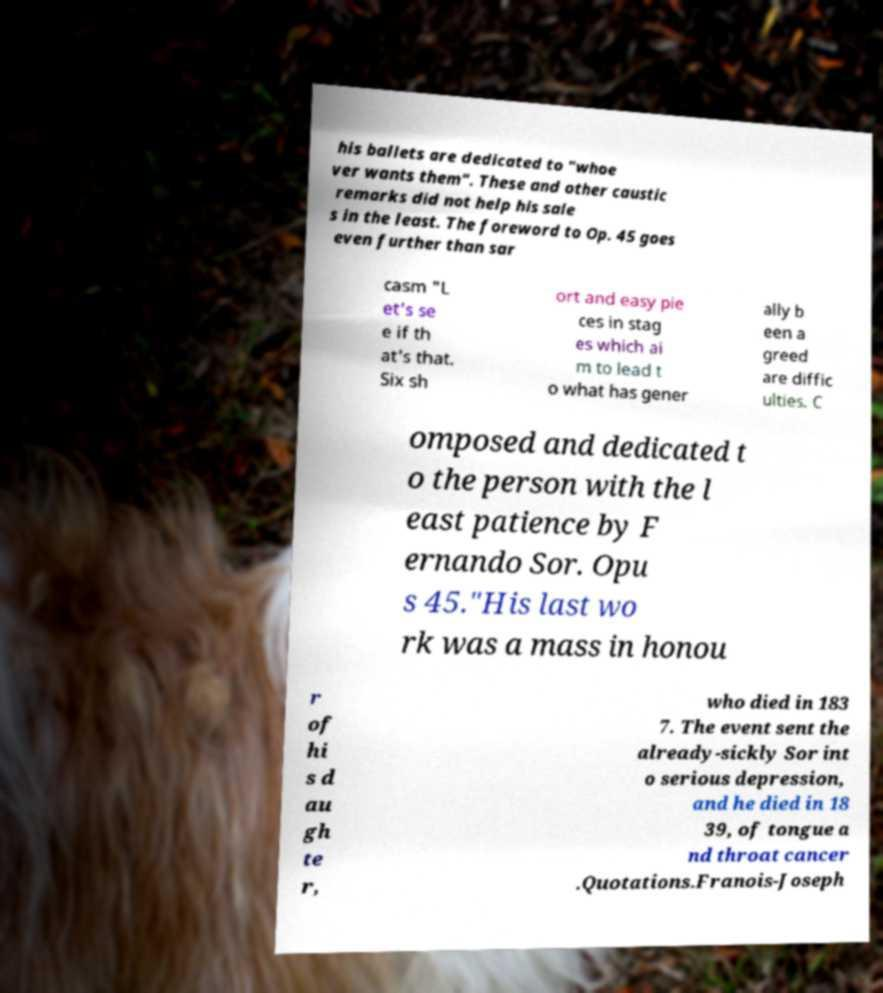Please read and relay the text visible in this image. What does it say? his ballets are dedicated to "whoe ver wants them". These and other caustic remarks did not help his sale s in the least. The foreword to Op. 45 goes even further than sar casm "L et's se e if th at's that. Six sh ort and easy pie ces in stag es which ai m to lead t o what has gener ally b een a greed are diffic ulties. C omposed and dedicated t o the person with the l east patience by F ernando Sor. Opu s 45."His last wo rk was a mass in honou r of hi s d au gh te r, who died in 183 7. The event sent the already-sickly Sor int o serious depression, and he died in 18 39, of tongue a nd throat cancer .Quotations.Franois-Joseph 